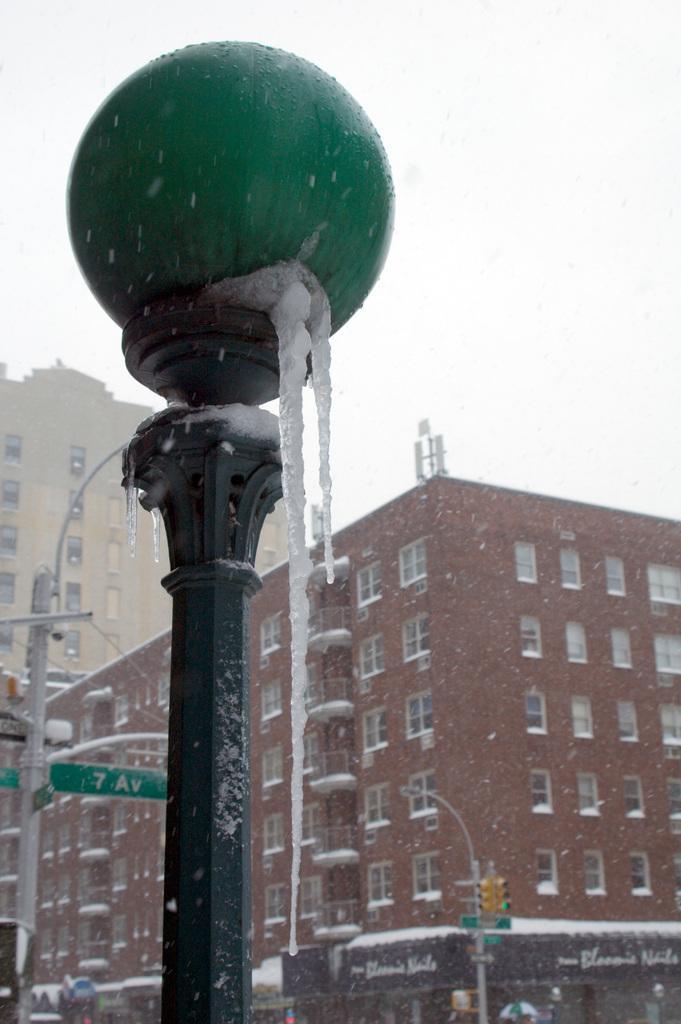Please provide a concise description of this image. In this image we can see a street pole, street light, buildings, traffic signals, sky and stalls. 